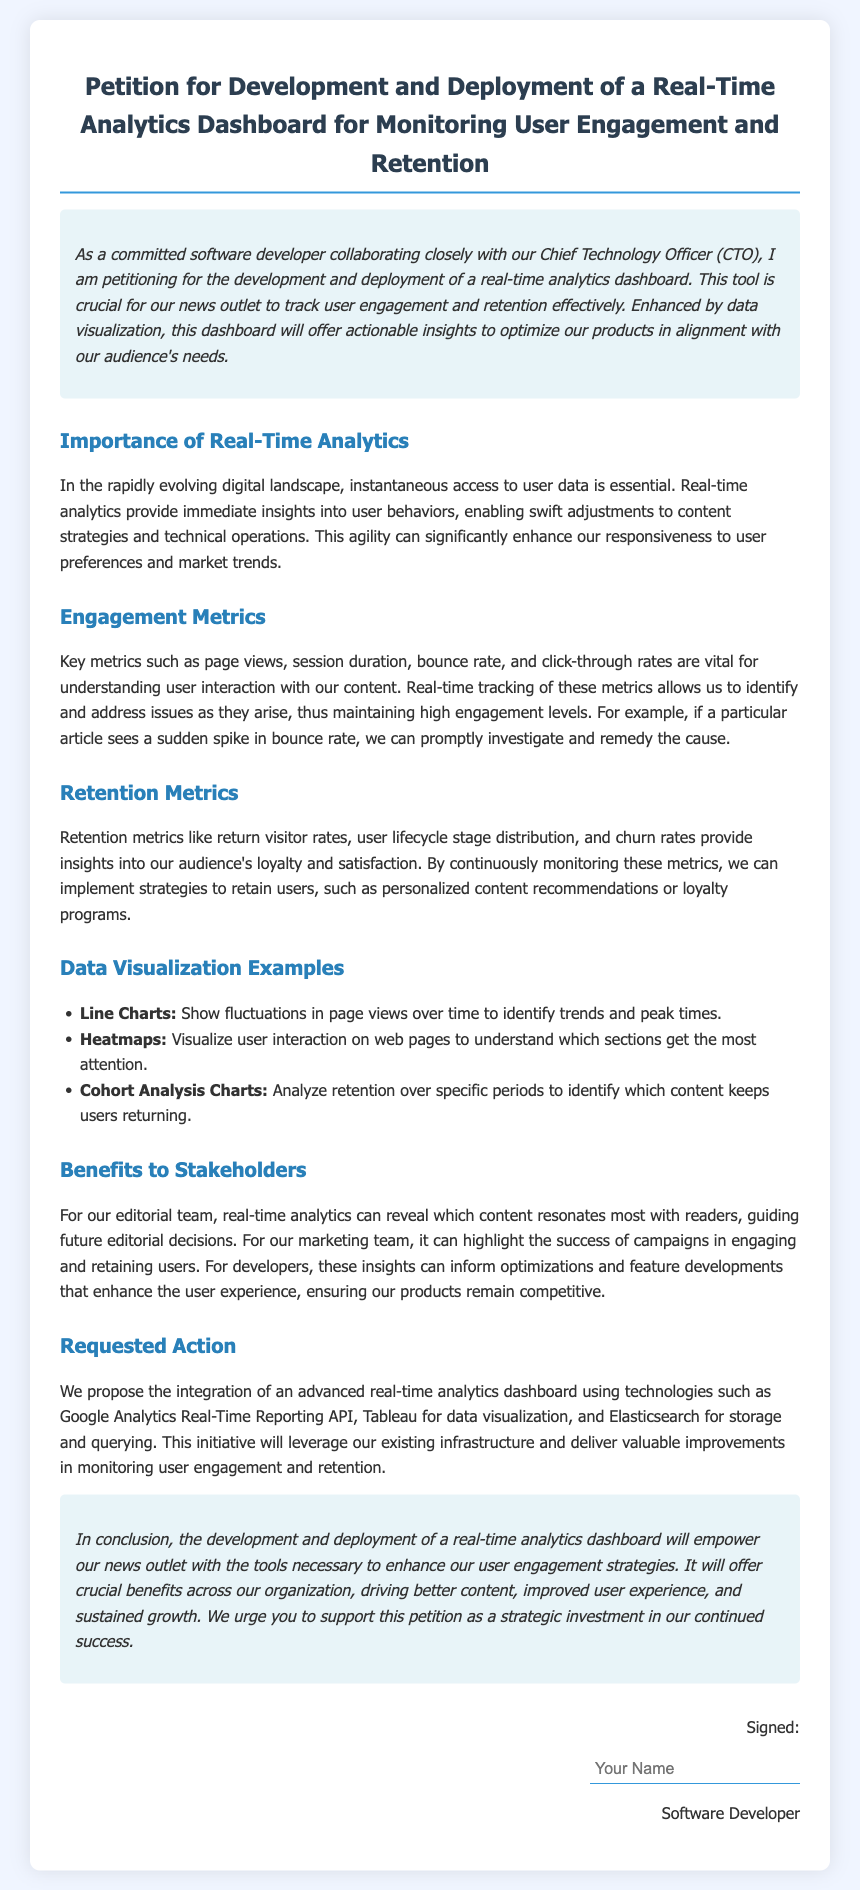what is the title of the petition? The title of the petition is found at the top of the document.
Answer: Petition for Development and Deployment of a Real-Time Analytics Dashboard for Monitoring User Engagement and Retention who is the petition directed by? The document states that it is initiated by a specific role within the organization.
Answer: Software Developer what is one proposed technology for the dashboard? The document lists several technologies proposed for the integration of the dashboard, providing a specific example.
Answer: Google Analytics Real-Time Reporting API what user engagement metric is mentioned first? The first engagement metric mentioned in the document highlights a key aspect of user interaction.
Answer: Page views which chart type is suggested for visualizing user interactions? The document outlines data visualization examples, naming a specific chart type for user interaction.
Answer: Heatmaps what is the aim of the real-time analytics dashboard? The purpose of the dashboard is specified in the introduction of the document, summarizing its main objective.
Answer: To monitor user engagement and retention how many data visualization examples are provided? The document lists multiple examples of data visualization types, allowing identification of the total count.
Answer: Three what benefit does real-time analytics provide to the marketing team? The document describes a specific advantage for the marketing team regarding their effectiveness.
Answer: Highlight the success of campaigns what is the conclusion of the petition? The conclusion sums up the importance and necessity of the dashboard, encapsulated in a brief statement.
Answer: Empower our news outlet with the tools necessary to enhance our user engagement strategies 